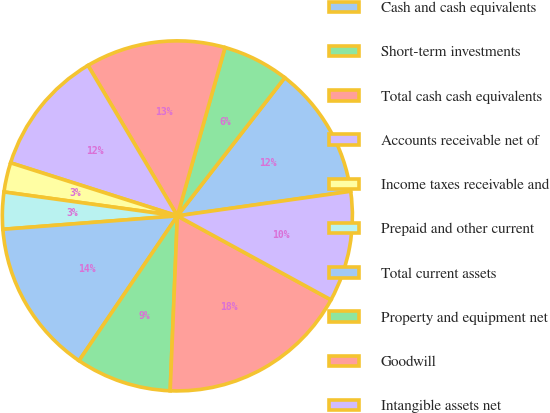Convert chart to OTSL. <chart><loc_0><loc_0><loc_500><loc_500><pie_chart><fcel>Cash and cash equivalents<fcel>Short-term investments<fcel>Total cash cash equivalents<fcel>Accounts receivable net of<fcel>Income taxes receivable and<fcel>Prepaid and other current<fcel>Total current assets<fcel>Property and equipment net<fcel>Goodwill<fcel>Intangible assets net<nl><fcel>12.24%<fcel>6.12%<fcel>12.92%<fcel>11.56%<fcel>2.72%<fcel>3.4%<fcel>14.28%<fcel>8.84%<fcel>17.69%<fcel>10.2%<nl></chart> 